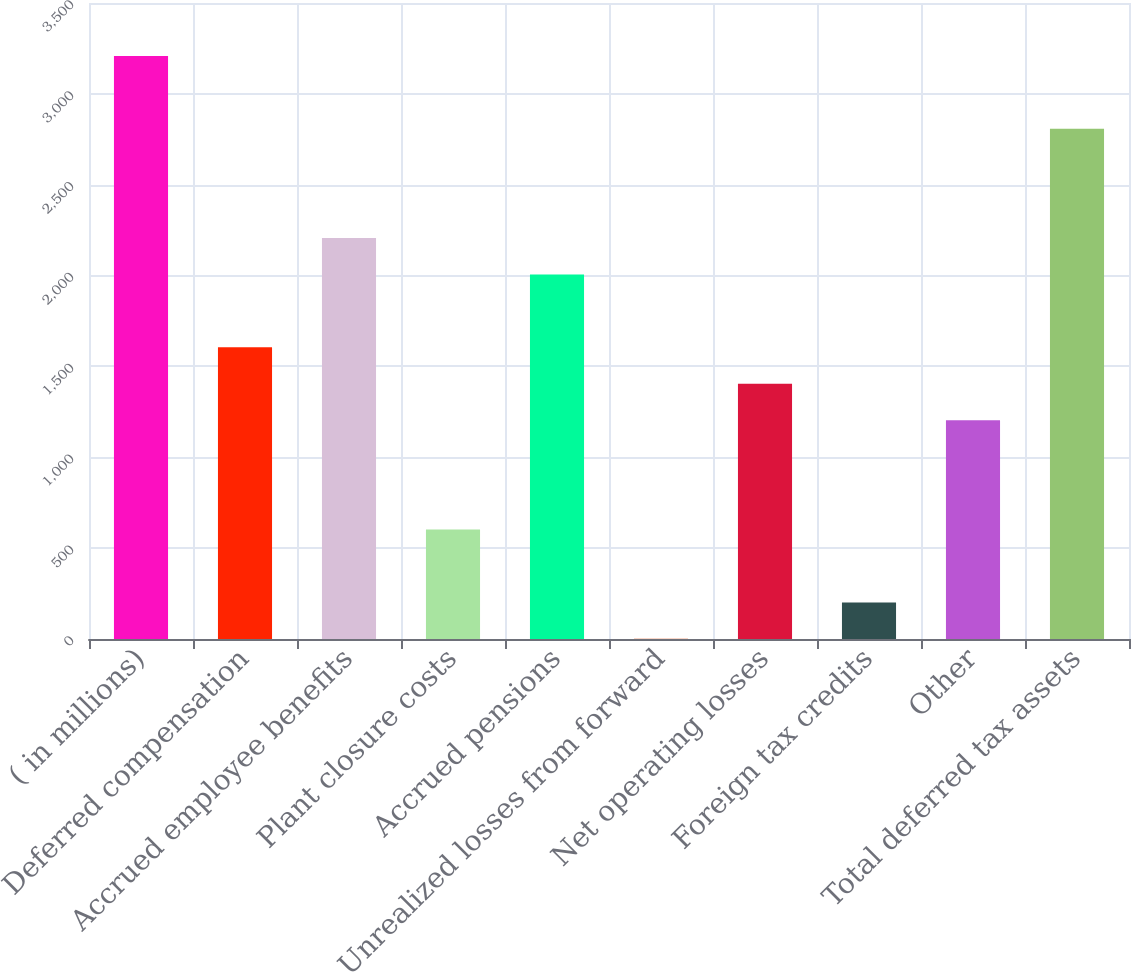Convert chart. <chart><loc_0><loc_0><loc_500><loc_500><bar_chart><fcel>( in millions)<fcel>Deferred compensation<fcel>Accrued employee benefits<fcel>Plant closure costs<fcel>Accrued pensions<fcel>Unrealized losses from forward<fcel>Net operating losses<fcel>Foreign tax credits<fcel>Other<fcel>Total deferred tax assets<nl><fcel>3209<fcel>1605<fcel>2206.5<fcel>602.5<fcel>2006<fcel>1<fcel>1404.5<fcel>201.5<fcel>1204<fcel>2808<nl></chart> 